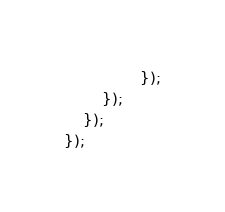<code> <loc_0><loc_0><loc_500><loc_500><_JavaScript_>                });
        });
    });
});
</code> 